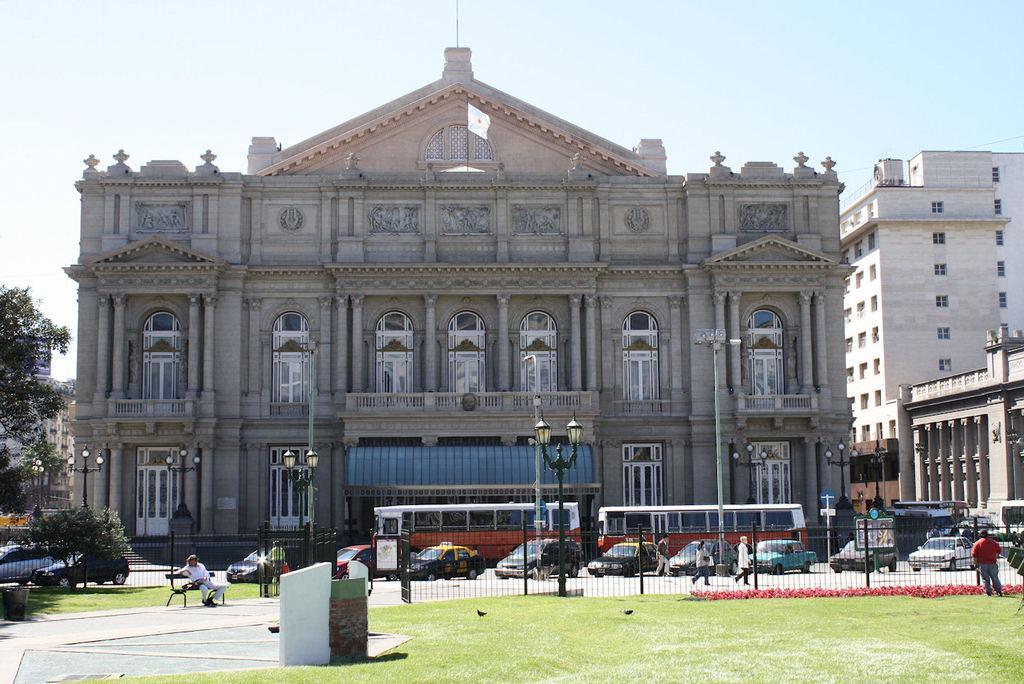Can you describe this image briefly? In this image I can see few vehicles on the road and I can see group of people, some standing and some are walking, few light poles, the railing, few buildings in cream and brown color, trees in green color and the sky is in white color. 